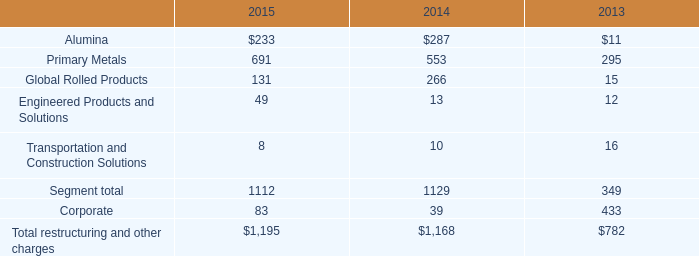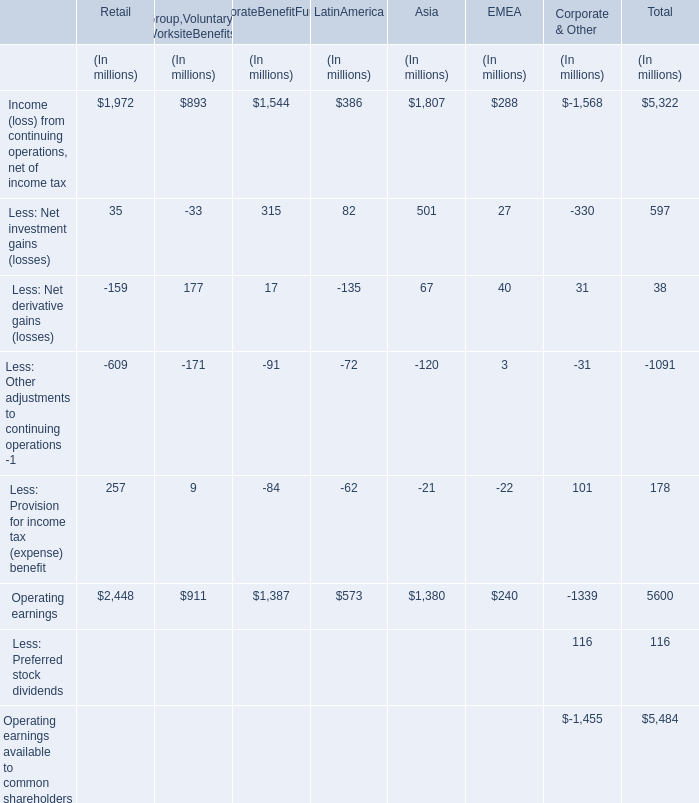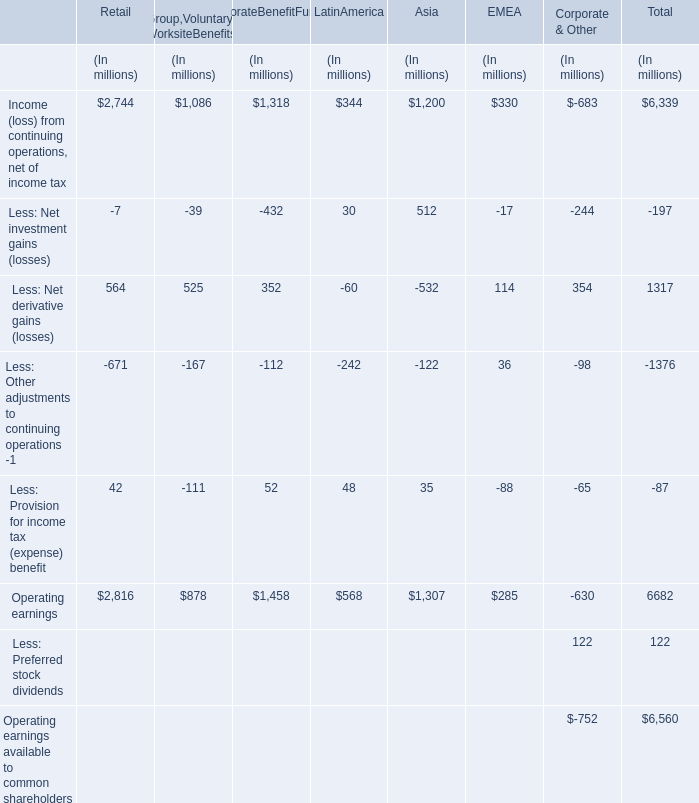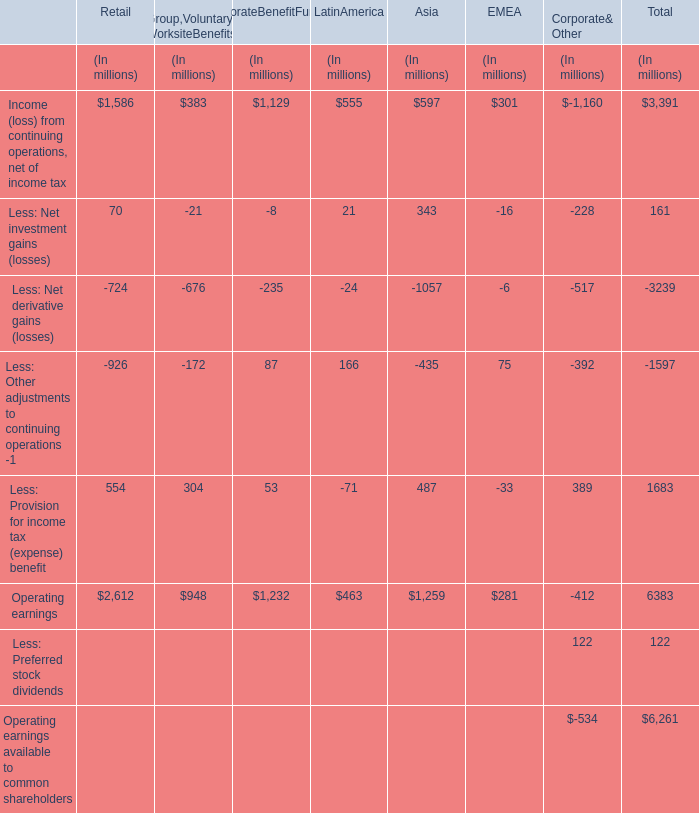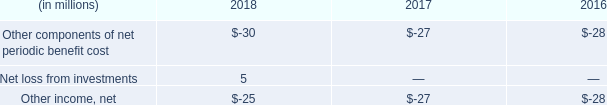What is the sum of Operating earnings for Asia and Income (loss) from continuing operations, net of income tax for EMEA? (in million) 
Computations: (1307 + 301)
Answer: 1608.0. 